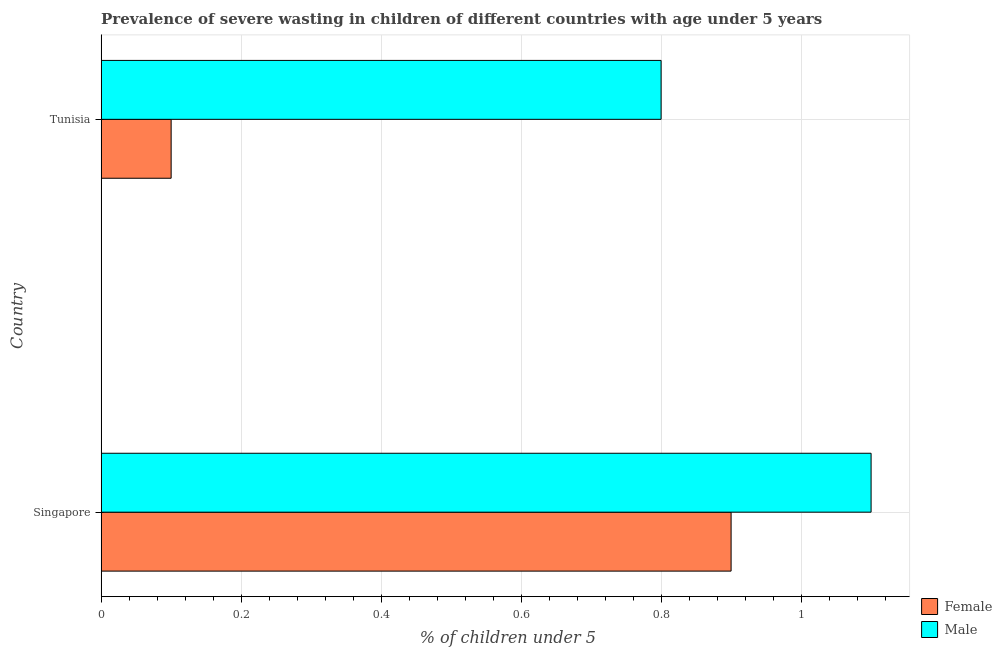How many groups of bars are there?
Provide a succinct answer. 2. How many bars are there on the 2nd tick from the bottom?
Keep it short and to the point. 2. What is the label of the 1st group of bars from the top?
Your answer should be very brief. Tunisia. What is the percentage of undernourished male children in Singapore?
Give a very brief answer. 1.1. Across all countries, what is the maximum percentage of undernourished male children?
Offer a very short reply. 1.1. Across all countries, what is the minimum percentage of undernourished male children?
Offer a very short reply. 0.8. In which country was the percentage of undernourished female children maximum?
Ensure brevity in your answer.  Singapore. In which country was the percentage of undernourished female children minimum?
Ensure brevity in your answer.  Tunisia. What is the total percentage of undernourished female children in the graph?
Make the answer very short. 1. What is the difference between the percentage of undernourished male children in Singapore and that in Tunisia?
Your answer should be compact. 0.3. What is the difference between the percentage of undernourished male children in Singapore and the percentage of undernourished female children in Tunisia?
Your answer should be compact. 1. What is the average percentage of undernourished female children per country?
Your answer should be compact. 0.5. Is the percentage of undernourished male children in Singapore less than that in Tunisia?
Your response must be concise. No. Is the difference between the percentage of undernourished male children in Singapore and Tunisia greater than the difference between the percentage of undernourished female children in Singapore and Tunisia?
Provide a succinct answer. No. What does the 1st bar from the bottom in Singapore represents?
Offer a very short reply. Female. How many countries are there in the graph?
Give a very brief answer. 2. What is the difference between two consecutive major ticks on the X-axis?
Keep it short and to the point. 0.2. Are the values on the major ticks of X-axis written in scientific E-notation?
Ensure brevity in your answer.  No. Does the graph contain grids?
Provide a short and direct response. Yes. How many legend labels are there?
Your answer should be very brief. 2. What is the title of the graph?
Keep it short and to the point. Prevalence of severe wasting in children of different countries with age under 5 years. What is the label or title of the X-axis?
Give a very brief answer.  % of children under 5. What is the  % of children under 5 of Female in Singapore?
Ensure brevity in your answer.  0.9. What is the  % of children under 5 of Male in Singapore?
Ensure brevity in your answer.  1.1. What is the  % of children under 5 of Female in Tunisia?
Provide a succinct answer. 0.1. What is the  % of children under 5 of Male in Tunisia?
Offer a very short reply. 0.8. Across all countries, what is the maximum  % of children under 5 in Female?
Your answer should be compact. 0.9. Across all countries, what is the maximum  % of children under 5 in Male?
Provide a short and direct response. 1.1. Across all countries, what is the minimum  % of children under 5 in Female?
Provide a short and direct response. 0.1. Across all countries, what is the minimum  % of children under 5 in Male?
Keep it short and to the point. 0.8. What is the total  % of children under 5 of Female in the graph?
Provide a succinct answer. 1. What is the total  % of children under 5 of Male in the graph?
Provide a short and direct response. 1.9. What is the difference between the  % of children under 5 of Male in Singapore and that in Tunisia?
Make the answer very short. 0.3. What is the average  % of children under 5 in Male per country?
Keep it short and to the point. 0.95. What is the difference between the  % of children under 5 of Female and  % of children under 5 of Male in Singapore?
Your answer should be very brief. -0.2. What is the difference between the  % of children under 5 in Female and  % of children under 5 in Male in Tunisia?
Keep it short and to the point. -0.7. What is the ratio of the  % of children under 5 in Male in Singapore to that in Tunisia?
Provide a succinct answer. 1.38. What is the difference between the highest and the second highest  % of children under 5 of Male?
Provide a succinct answer. 0.3. What is the difference between the highest and the lowest  % of children under 5 in Male?
Your response must be concise. 0.3. 